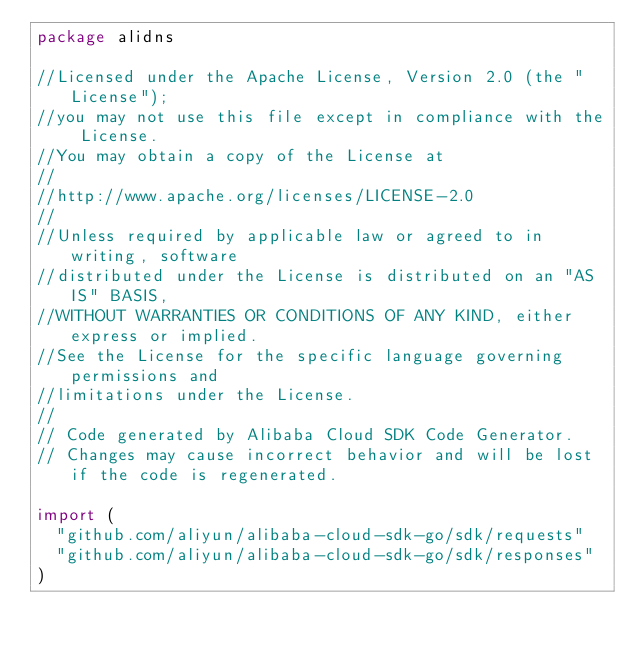<code> <loc_0><loc_0><loc_500><loc_500><_Go_>package alidns

//Licensed under the Apache License, Version 2.0 (the "License");
//you may not use this file except in compliance with the License.
//You may obtain a copy of the License at
//
//http://www.apache.org/licenses/LICENSE-2.0
//
//Unless required by applicable law or agreed to in writing, software
//distributed under the License is distributed on an "AS IS" BASIS,
//WITHOUT WARRANTIES OR CONDITIONS OF ANY KIND, either express or implied.
//See the License for the specific language governing permissions and
//limitations under the License.
//
// Code generated by Alibaba Cloud SDK Code Generator.
// Changes may cause incorrect behavior and will be lost if the code is regenerated.

import (
	"github.com/aliyun/alibaba-cloud-sdk-go/sdk/requests"
	"github.com/aliyun/alibaba-cloud-sdk-go/sdk/responses"
)
</code> 